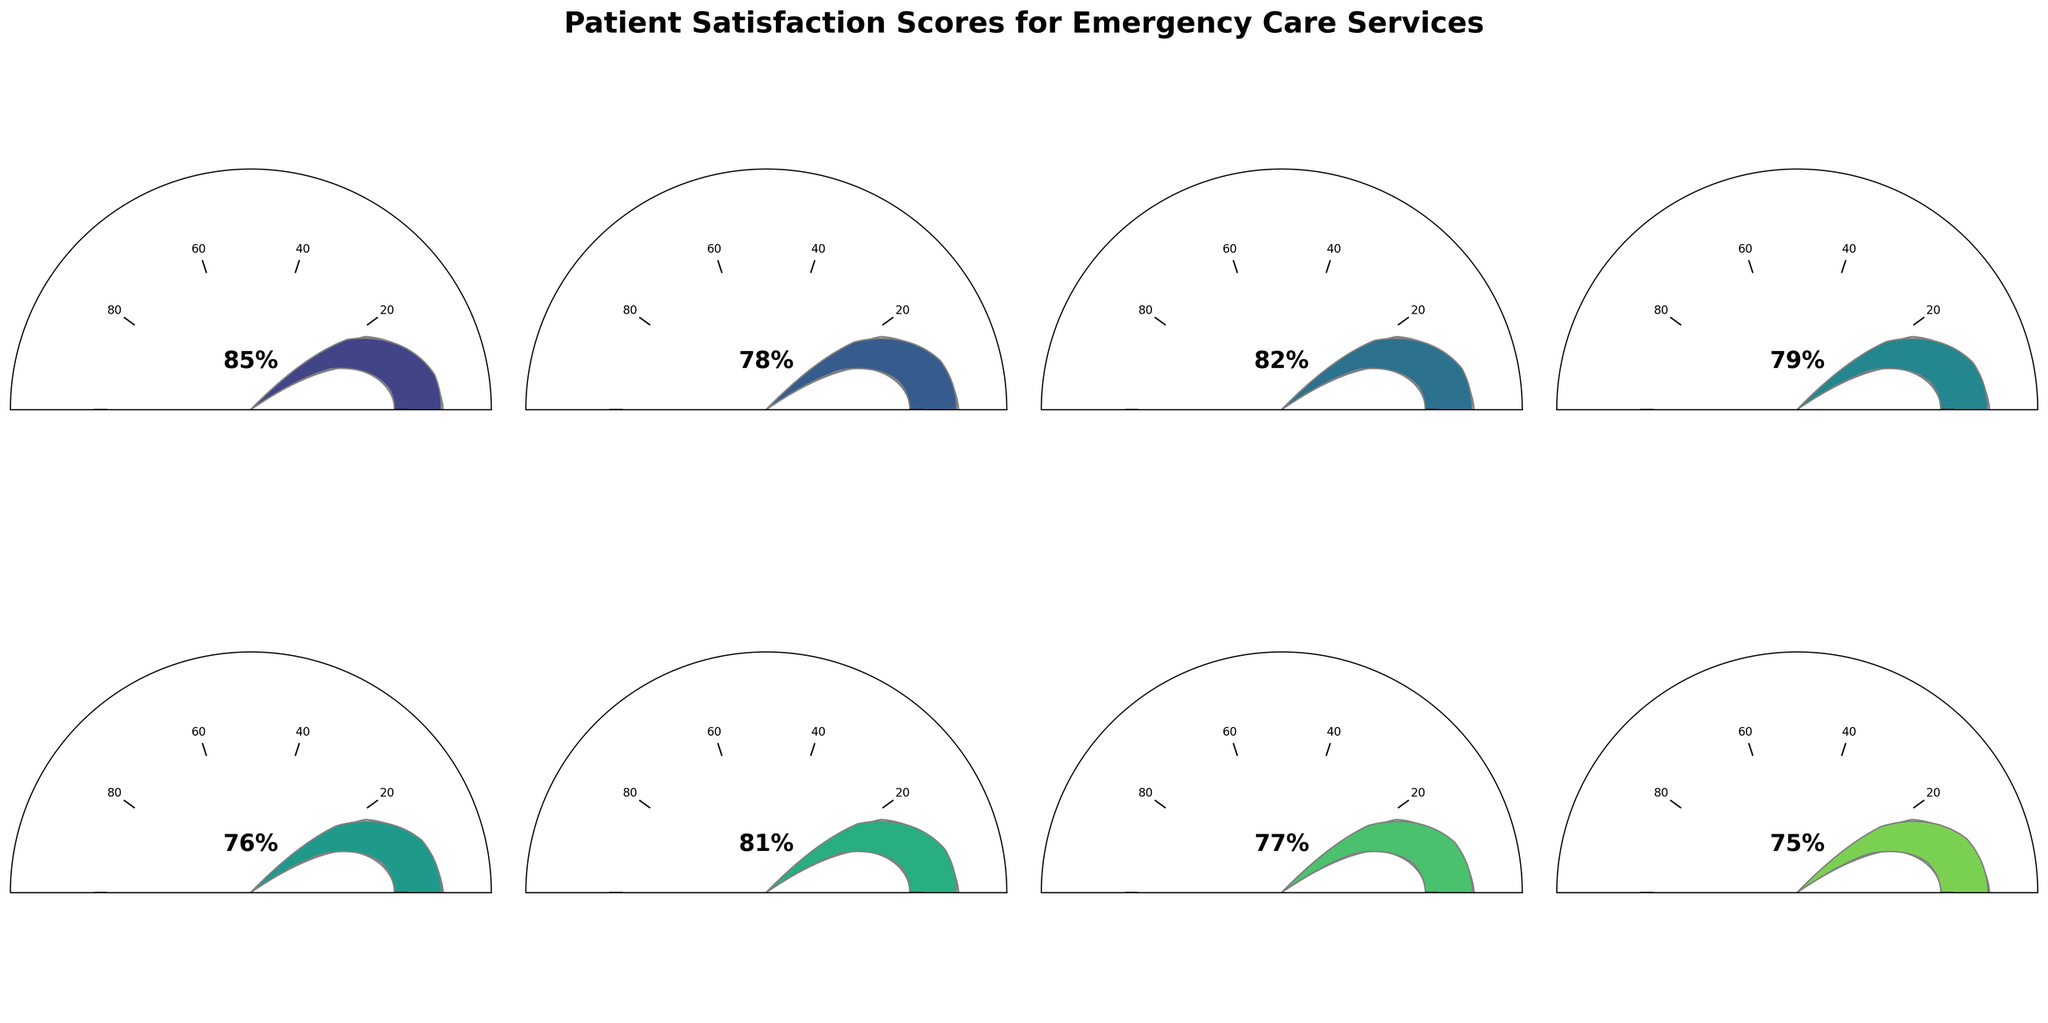What is the title of the figure? The title is typically displayed at the top of the figure, usually in a larger and bolder font to differentiate it from other text elements.
Answer: Patient Satisfaction Scores for Emergency Care Services How many hospitals are shown in the figure? Each subplot represents one hospital, and there are a total of 8 subplots in the figure.
Answer: 8 Which hospital has the highest patient satisfaction score? To find the hospital with the highest score, we look for the gauge chart with the needle farthest to the right. Mayo Clinic's gauge chart shows the highest score at 85%.
Answer: Mayo Clinic What is the patient satisfaction score of Cedars-Sinai Medical Center? We identify Cedars-Sinai Medical Center's subplot and look at the labeled score. The gauge shows a satisfaction score of 77%.
Answer: 77% Which hospital has the lowest patient satisfaction score? To find the hospital with the lowest score, we look for the gauge chart with the needle farthest to the left. Mount Sinai Hospital's gauge chart shows the lowest score at 75%.
Answer: Mount Sinai Hospital What is the average patient satisfaction score across all hospitals? Sum all the satisfaction scores and divide by the number of hospitals. The scores are 85, 78, 82, 79, 76, 81, 77, 75, totaling 633. The average is 633/8 = 79.125.
Answer: 79.125 How many hospitals have a satisfaction score greater than 80? Count the number of gauge charts where the needle is beyond the 80 mark. Mayo Clinic, Johns Hopkins Hospital, and UCLA Medical Center have scores over 80.
Answer: 3 Compare the satisfaction scores of Massachusetts General Hospital and NewYork-Presbyterian Hospital. Which one is higher? Compare the labeled scores directly. Massachusetts General Hospital has 79%, while NewYork-Presbyterian Hospital has 76%.
Answer: Massachusetts General Hospital Is the satisfaction score for Johns Hopkins Hospital higher than that of Cleveland Clinic? Compare the labeled scores directly. Johns Hopkins Hospital has 82%, while Cleveland Clinic has 78%.
Answer: Yes What is the range of satisfaction scores displayed in the figure? The range is the difference between the highest and lowest scores. The highest score is 85% (Mayo Clinic) and the lowest score is 75% (Mount Sinai Hospital), so the range is 85-75.
Answer: 10 